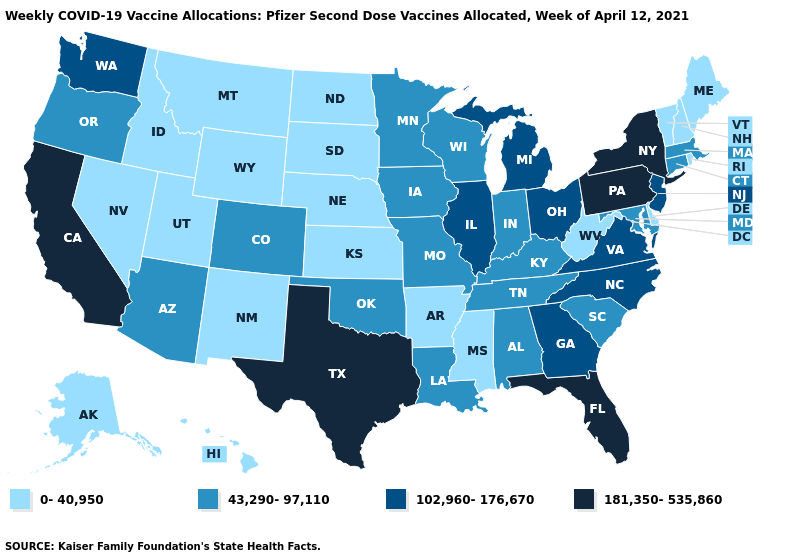Which states have the highest value in the USA?
Short answer required. California, Florida, New York, Pennsylvania, Texas. What is the highest value in states that border Colorado?
Answer briefly. 43,290-97,110. Does Maryland have the lowest value in the South?
Keep it brief. No. What is the lowest value in the USA?
Short answer required. 0-40,950. Does the first symbol in the legend represent the smallest category?
Be succinct. Yes. What is the value of Maryland?
Short answer required. 43,290-97,110. What is the lowest value in the MidWest?
Concise answer only. 0-40,950. Among the states that border Virginia , which have the lowest value?
Concise answer only. West Virginia. Name the states that have a value in the range 102,960-176,670?
Short answer required. Georgia, Illinois, Michigan, New Jersey, North Carolina, Ohio, Virginia, Washington. What is the highest value in the USA?
Be succinct. 181,350-535,860. Does New Mexico have a lower value than Utah?
Answer briefly. No. What is the value of Tennessee?
Keep it brief. 43,290-97,110. Is the legend a continuous bar?
Answer briefly. No. Does Vermont have a lower value than Ohio?
Short answer required. Yes. What is the lowest value in states that border Maryland?
Give a very brief answer. 0-40,950. 